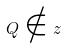<formula> <loc_0><loc_0><loc_500><loc_500>Q \notin z</formula> 